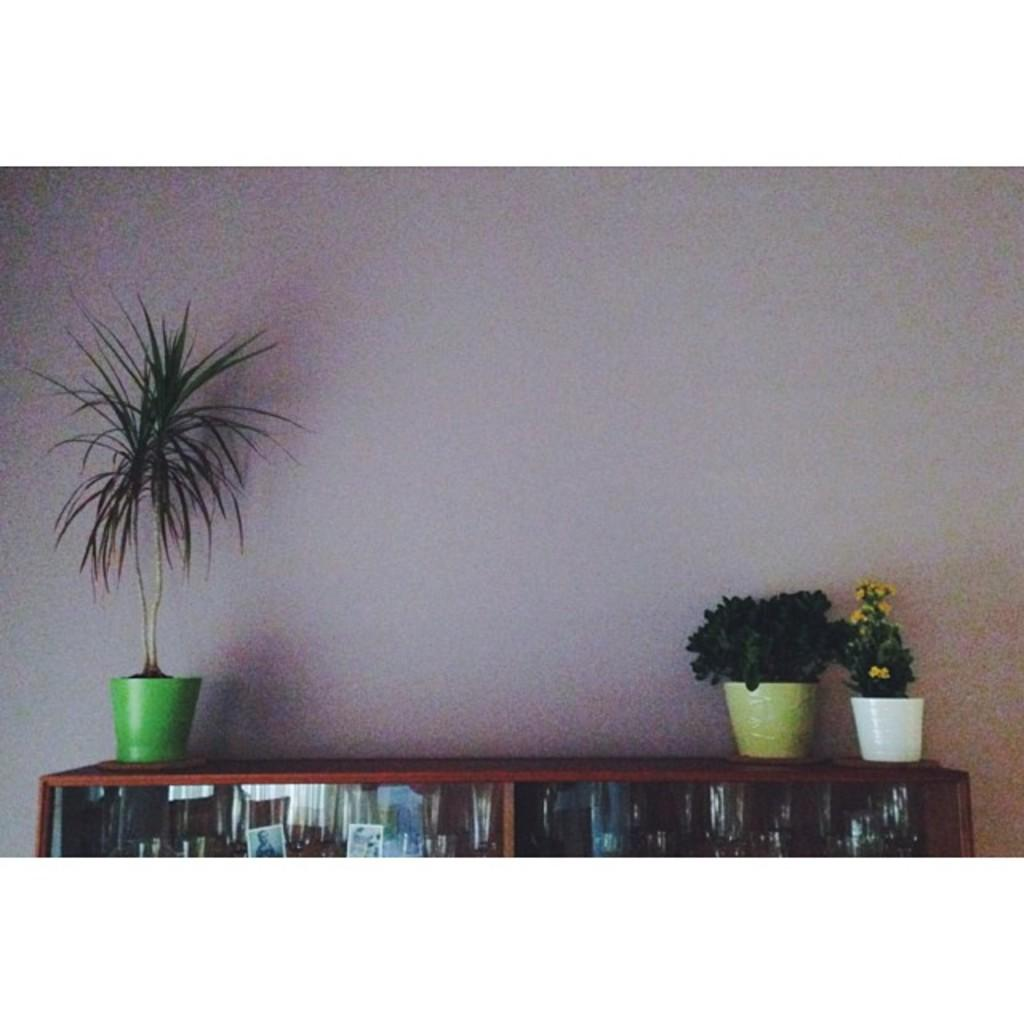What type of furniture is present in the image? There is a cupboard in the image. What can be found inside the cupboard? There are objects inside the cupboard. What type of vegetation is present in the image? There are potted plants in the image. What can be seen in the background of the image? There is a wall visible in the background of the image. What type of owl can be seen perched on the cupboard in the image? There is no owl present in the image; it only features a cupboard, objects inside it, potted plants, and a wall in the background. 